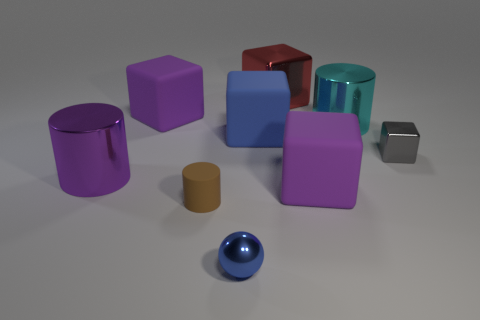Are there more purple objects to the right of the red shiny thing than red balls?
Offer a very short reply. Yes. Is the number of purple rubber things in front of the cyan metal cylinder less than the number of big green metal cylinders?
Offer a terse response. No. What number of small rubber cylinders have the same color as the tiny block?
Make the answer very short. 0. There is a big object that is right of the large blue cube and behind the large cyan shiny cylinder; what is its material?
Your response must be concise. Metal. There is a metallic object that is in front of the brown cylinder; is it the same color as the rubber object behind the cyan cylinder?
Offer a very short reply. No. How many yellow things are either big matte objects or small matte cylinders?
Give a very brief answer. 0. Are there fewer purple cylinders on the right side of the gray metallic block than purple matte blocks in front of the large cyan object?
Ensure brevity in your answer.  Yes. Is there a purple shiny cylinder of the same size as the cyan object?
Your response must be concise. Yes. There is a shiny cube that is to the right of the cyan metal object; is its size the same as the big blue rubber block?
Your answer should be compact. No. Are there more cyan things than metal cylinders?
Your answer should be very brief. No. 